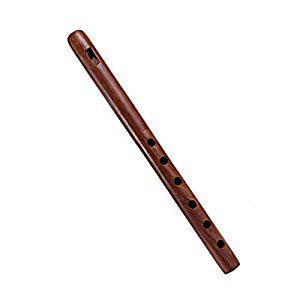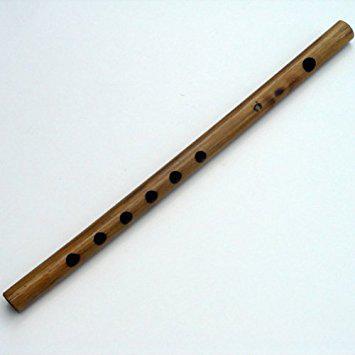The first image is the image on the left, the second image is the image on the right. For the images displayed, is the sentence "Both flutes are brown and presumably wooden, with little to no decoration." factually correct? Answer yes or no. Yes. 